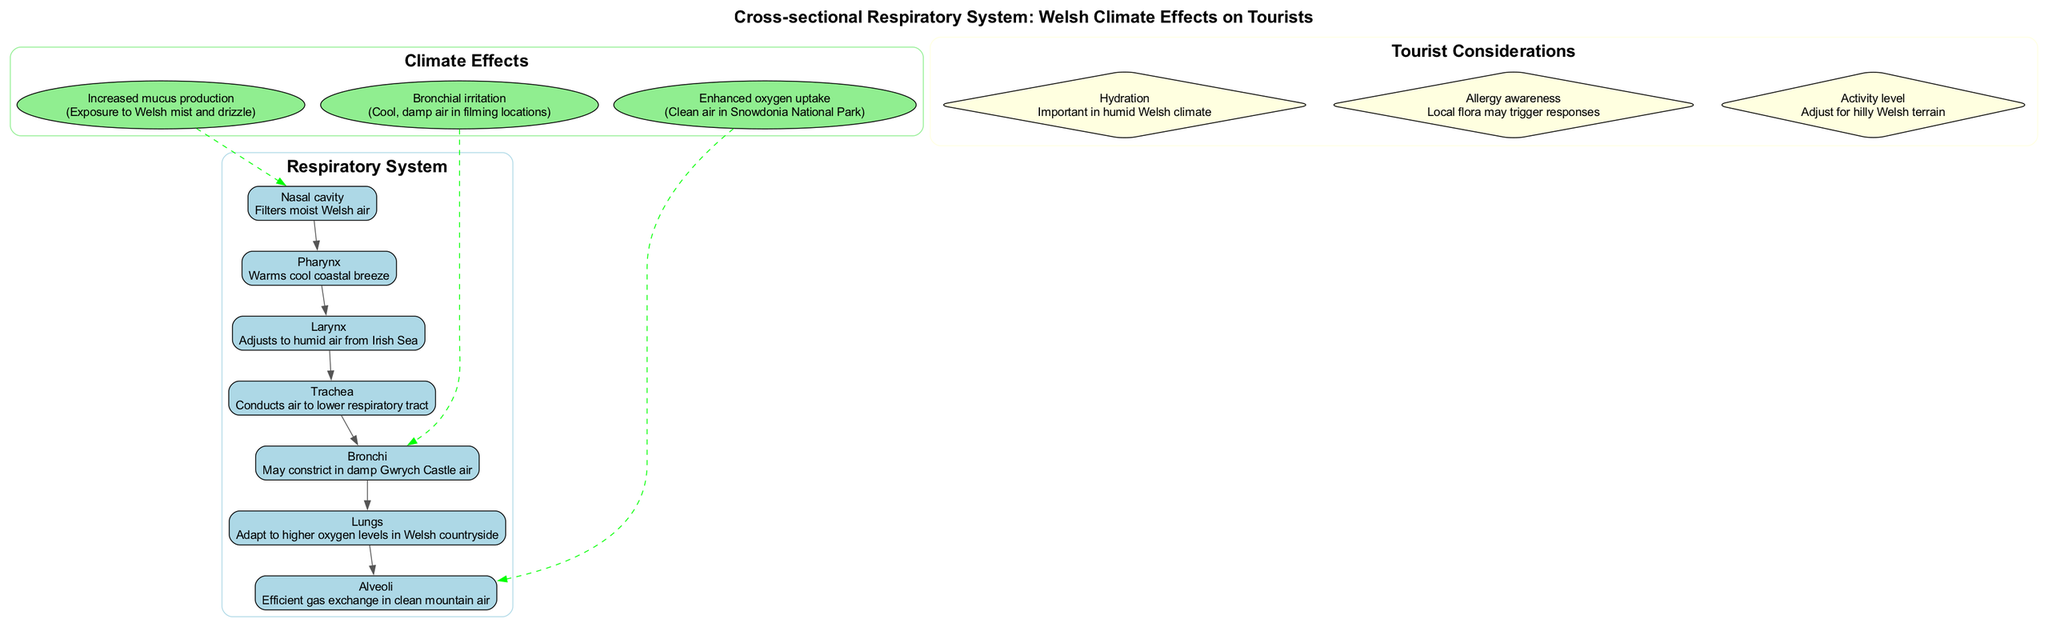What is the function of the nasal cavity in the diagram? The nasal cavity filters moist Welsh air, which is stated in its description on the diagram.
Answer: Filters moist Welsh air How many main components are there in the respiratory system depicted? The diagram lists seven main components of the respiratory system, as seen in the cluster labeled 'Respiratory System'.
Answer: Seven What effect does cool, damp air have on the bronchi? The effect of cool, damp air on the bronchi is bronchial irritation, as mentioned in the climate effects section linked to the bronchi.
Answer: Bronchial irritation What does the respiratory system adapt to in the lungs? The lungs adapt to higher oxygen levels in the Welsh countryside, as described in their section.
Answer: Higher oxygen levels in Welsh countryside Which part of the respiratory system is affected by exposure to Welsh mist and drizzle? Increased mucus production is linked to the nasal cavity, as indicated in the climate effects related to exposure to Welsh mist and drizzle.
Answer: Nasal cavity Identify one tourist consideration related to the local climate in Wales. The diagram lists hydration as important in the humid Welsh climate, which is found in the tourist considerations section.
Answer: Hydration How does the clean air in Snowdonia National Park impact the alveoli? The alveoli experience enhanced oxygen uptake due to the clean air in Snowdonia National Park, indicating an improvement in gas exchange.
Answer: Enhanced oxygen uptake What connection is noted between the bronchi and the effects of climate? The bronchi may constrict in damp Gwrych Castle air, showing a direct relationship between the bronchi and local climate conditions.
Answer: May constrict in damp Gwrych Castle air What shape is used to represent the main components in the diagram? The main components of the respiratory system are represented as boxes, according to the descriptive attributes for the nodes in the diagram.
Answer: Box 